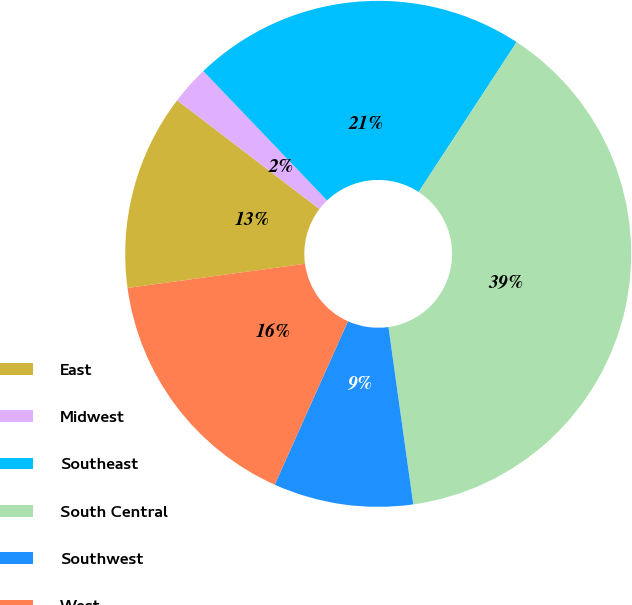Convert chart. <chart><loc_0><loc_0><loc_500><loc_500><pie_chart><fcel>East<fcel>Midwest<fcel>Southeast<fcel>South Central<fcel>Southwest<fcel>West<nl><fcel>12.53%<fcel>2.47%<fcel>21.37%<fcel>38.57%<fcel>8.92%<fcel>16.14%<nl></chart> 